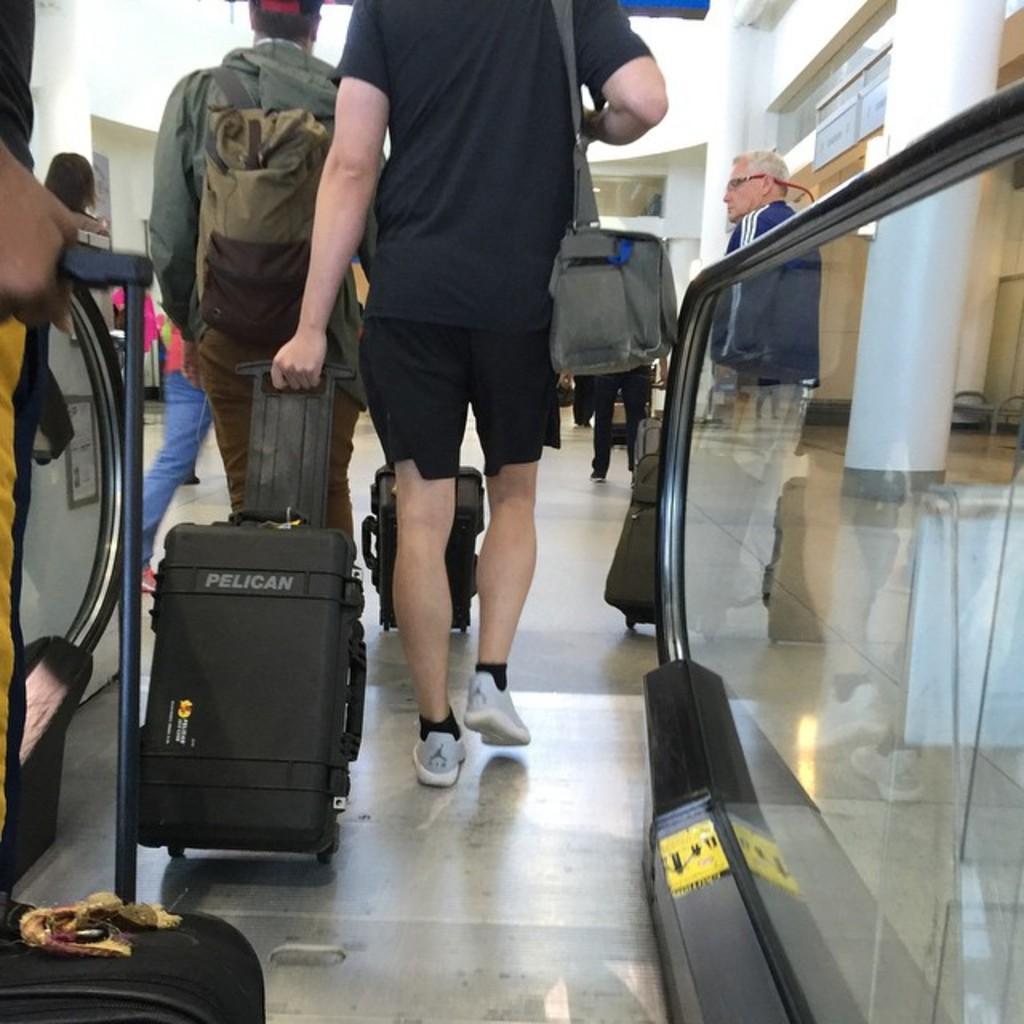Can you describe this image briefly? These persons are walking, as there is a leg movement. This persons are holding luggage and wire bag. This is pillar. 